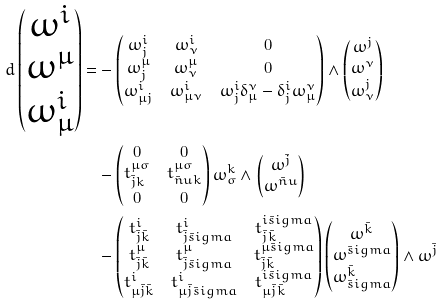Convert formula to latex. <formula><loc_0><loc_0><loc_500><loc_500>d \begin{pmatrix} \omega ^ { i } \\ \omega ^ { \mu } \\ \omega ^ { i } _ { \mu } \end{pmatrix} = & - \begin{pmatrix} \omega ^ { i } _ { j } & \omega ^ { i } _ { \nu } & 0 \\ \omega ^ { \mu } _ { j } & \omega ^ { \mu } _ { \nu } & 0 \\ \omega ^ { i } _ { \mu j } & \omega ^ { i } _ { \mu \nu } & \omega ^ { i } _ { j } \delta ^ { \nu } _ { \mu } - \delta ^ { i } _ { j } \omega ^ { \nu } _ { \mu } \end{pmatrix} \wedge \begin{pmatrix} \omega ^ { j } \\ \omega ^ { \nu } \\ \omega ^ { j } _ { \nu } \end{pmatrix} \\ & - \begin{pmatrix} 0 & 0 \\ t ^ { \mu \sigma } _ { \bar { j } k } & t ^ { \mu \sigma } _ { \bar { n } u k } \\ 0 & 0 \end{pmatrix} \omega ^ { k } _ { \sigma } \wedge \begin{pmatrix} \omega ^ { \bar { j } } \\ \omega ^ { \bar { n } u } \end{pmatrix} \\ & - \begin{pmatrix} t ^ { i } _ { \bar { j } \bar { k } } & t ^ { i } _ { \bar { j } \bar { s } i g m a } & t ^ { i \bar { s } i g m a } _ { \bar { j } \bar { k } } \\ t ^ { \mu } _ { \bar { j } \bar { k } } & t ^ { \mu } _ { \bar { j } \bar { s } i g m a } & t ^ { \mu \bar { s } i g m a } _ { \bar { j } \bar { k } } \\ t ^ { i } _ { \mu \bar { j } \bar { k } } & t ^ { i } _ { \mu \bar { j } \bar { s } i g m a } & t ^ { i \bar { s } i g m a } _ { \mu \bar { j } \bar { k } } \end{pmatrix} \begin{pmatrix} \omega ^ { \bar { k } } \\ \omega ^ { \bar { s } i g m a } \\ \omega ^ { \bar { k } } _ { \bar { s } i g m a } \end{pmatrix} \wedge \omega ^ { \bar { j } }</formula> 